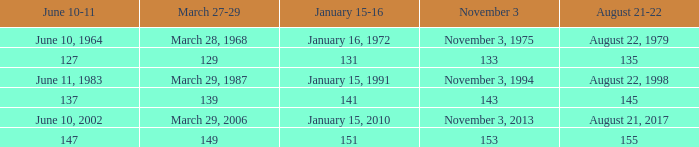What is shown for  august 21-22 when november 3 is november 3, 1994? August 22, 1998. 